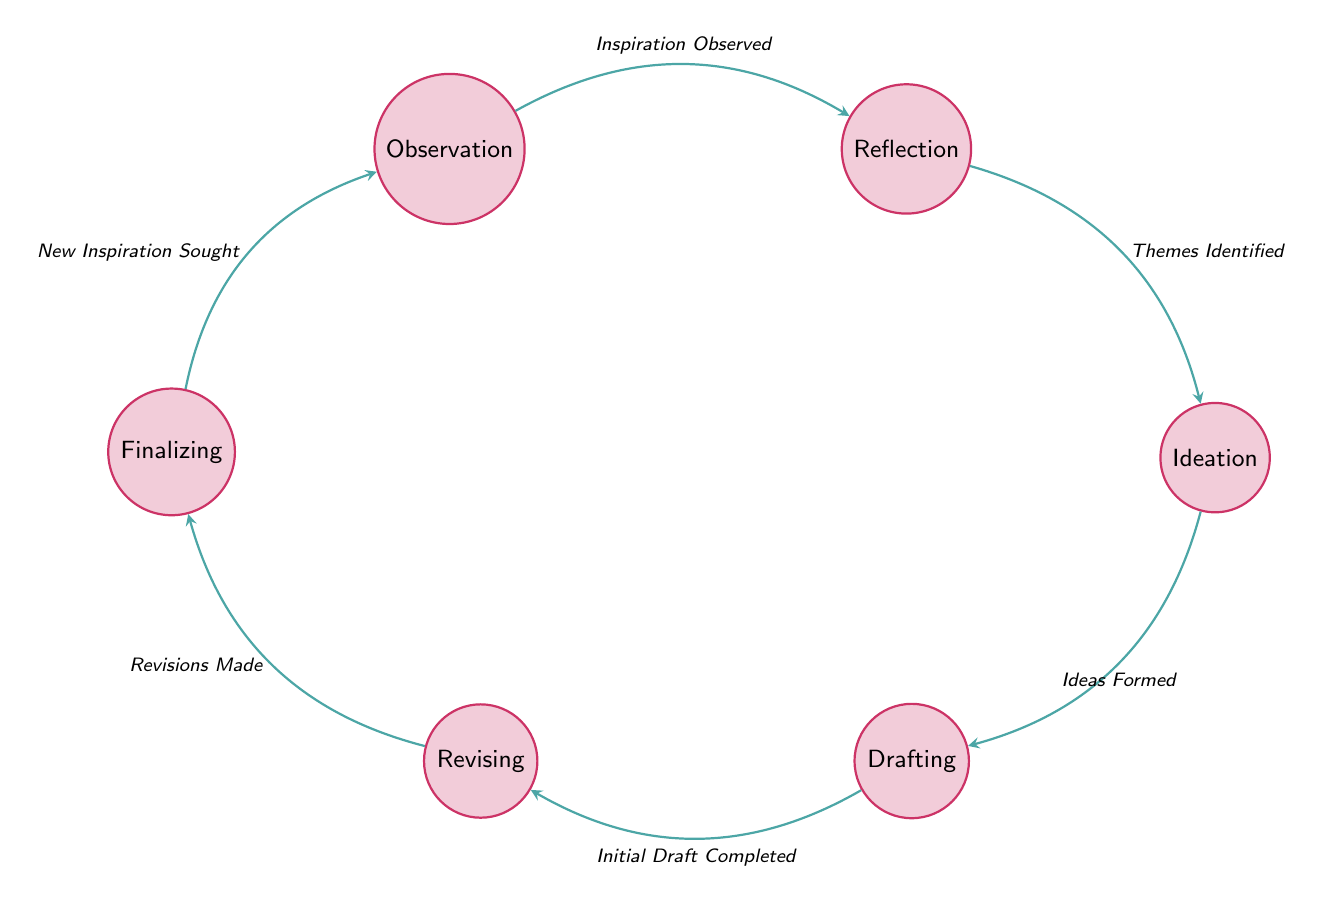What is the first state in the process? The first state listed in the diagram is "Observation." This can be identified as it is the starting point of the finite state machine and has no incoming edges from any other state.
Answer: Observation Which state comes after Reflection? Following the state "Reflection," the next state in the transition is "Ideation." This connection is indicated by the arrow labeled "Themes Identified" leading from Reflection to Ideation.
Answer: Ideation How many states are there in total? The diagram lists a total of six unique states: Observation, Reflection, Ideation, Drafting, Revising, and Finalizing. This can be counted directly from the states section of the diagram.
Answer: 6 What triggers the transition from Drafting to Revising? The transition from "Drafting" to "Revising" is triggered by "Initial Draft Completed." This is indicated by the corresponding label on the directed edge connecting these two states.
Answer: Initial Draft Completed What is the relationship between Finalizing and Observation? "Finalizing" and "Observation" are connected in a loop, where the transition from Finalizing back to Observation is triggered by "New Inspiration Sought." This shows that the process can cycle back to the beginning after reaching the final state.
Answer: New Inspiration Sought Which state occurs before Ideation? The state that occurs immediately before "Ideation" is "Reflection." This is evidenced by the transition leading into Ideation from Reflection marked with the label "Themes Identified."
Answer: Reflection How many transitions are there in the diagram? There are a total of six transitions represented in the finite state machine, each corresponding to the movement between states as indicated by the arrows. This can be tallied from the transitions section.
Answer: 6 What does the movement from Revisions to Finalizing indicate? The movement from "Revising" to "Finalizing" indicates that "Revisions Made" is the trigger for this transition. This means that only after the revisions are completed does the poet move to finalize the work.
Answer: Revisions Made 